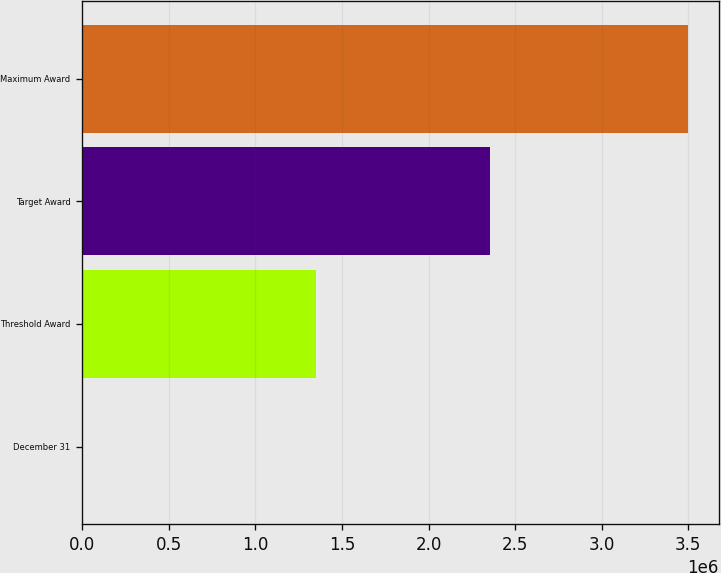<chart> <loc_0><loc_0><loc_500><loc_500><bar_chart><fcel>December 31<fcel>Threshold Award<fcel>Target Award<fcel>Maximum Award<nl><fcel>2005<fcel>1.35239e+06<fcel>2.35673e+06<fcel>3.49909e+06<nl></chart> 